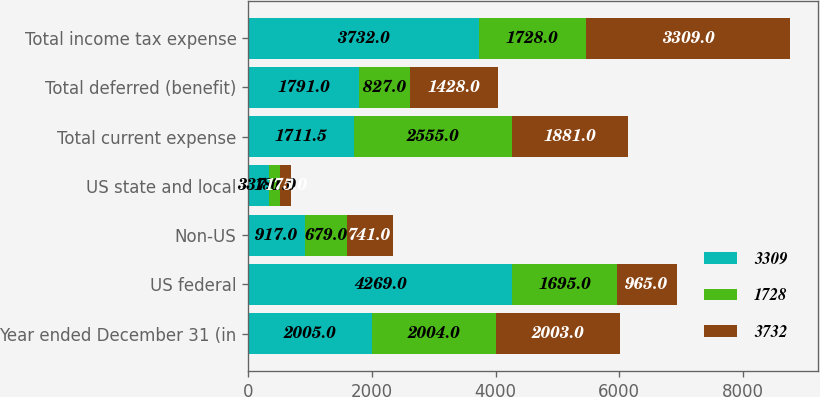Convert chart. <chart><loc_0><loc_0><loc_500><loc_500><stacked_bar_chart><ecel><fcel>Year ended December 31 (in<fcel>US federal<fcel>Non-US<fcel>US state and local<fcel>Total current expense<fcel>Total deferred (benefit)<fcel>Total income tax expense<nl><fcel>3309<fcel>2005<fcel>4269<fcel>917<fcel>337<fcel>1711.5<fcel>1791<fcel>3732<nl><fcel>1728<fcel>2004<fcel>1695<fcel>679<fcel>181<fcel>2555<fcel>827<fcel>1728<nl><fcel>3732<fcel>2003<fcel>965<fcel>741<fcel>175<fcel>1881<fcel>1428<fcel>3309<nl></chart> 